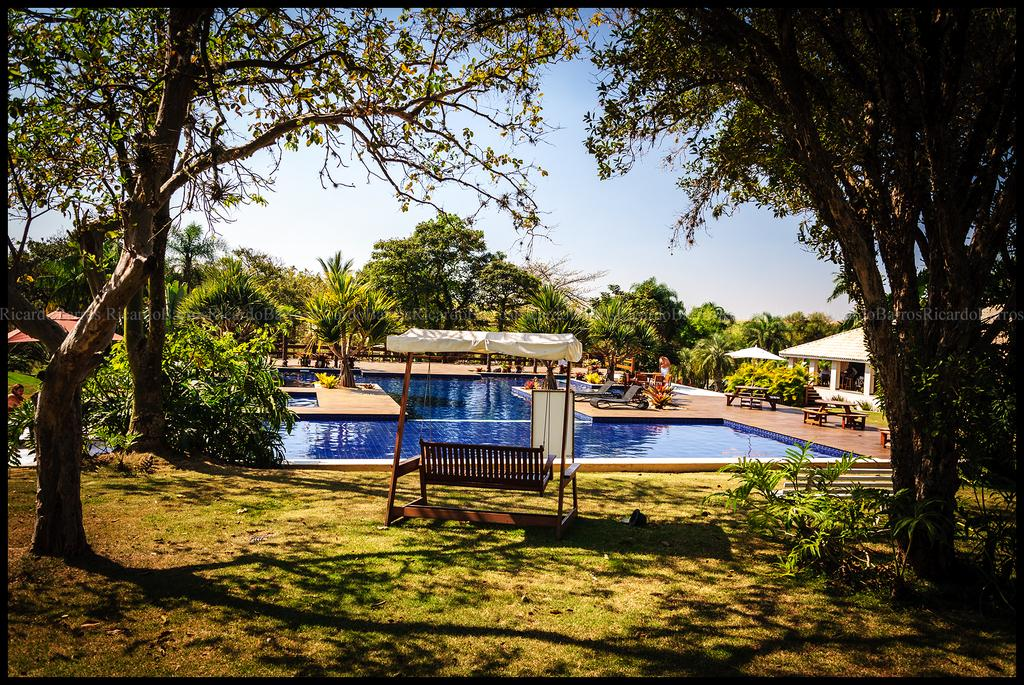What is the main feature in the image? There is a swimming pool in the image. What can be seen around the swimming pool? The swimming pool is surrounded by trees. What recreational item is visible in the middle of the image? There is a swing in the middle of the image. What type of structure is on the right side of the image? There is a shelter on the right side of the image. What type of leather is used to make the brush in the image? There is no brush or leather present in the image. 